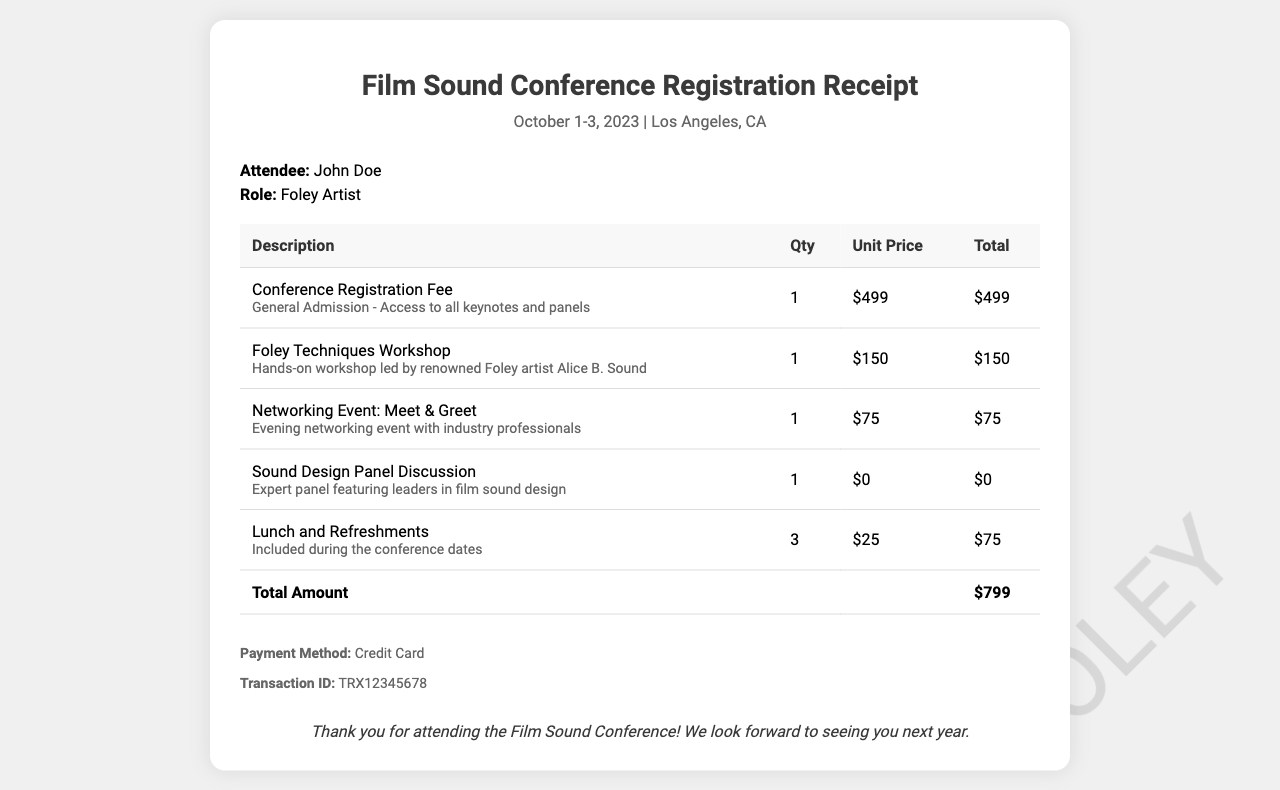What is the attendee's name? The attendee's name is listed in the document, specifically in the attendee section.
Answer: John Doe What was the total amount paid for registration? The total amount can be found in the total row of the table in the document.
Answer: $799 What was the date of the conference? The date of the conference is mentioned in the header section of the document.
Answer: October 1-3, 2023 How many workshops did the attendee register for? The documentation specifies that there were three main line items directly mentioning the workshops and events, leading to an aggregation.
Answer: 1 What is the role of the attendee? The attendee's role is clearly stated in the attendee section of the receipt.
Answer: Foley Artist Who was the instructor for the Foley Techniques Workshop? The instructor's name is provided in the details under the workshop description.
Answer: Alice B. Sound What was included in the lunch and refreshments? The document describes that lunch and refreshments were included during the conference dates.
Answer: Included What is the payment method used for the registration? The payment method is specified in the payment info section of the document.
Answer: Credit Card What is the transaction ID for the payment? The transaction ID is stated in the payment information section of the receipt.
Answer: TRX12345678 